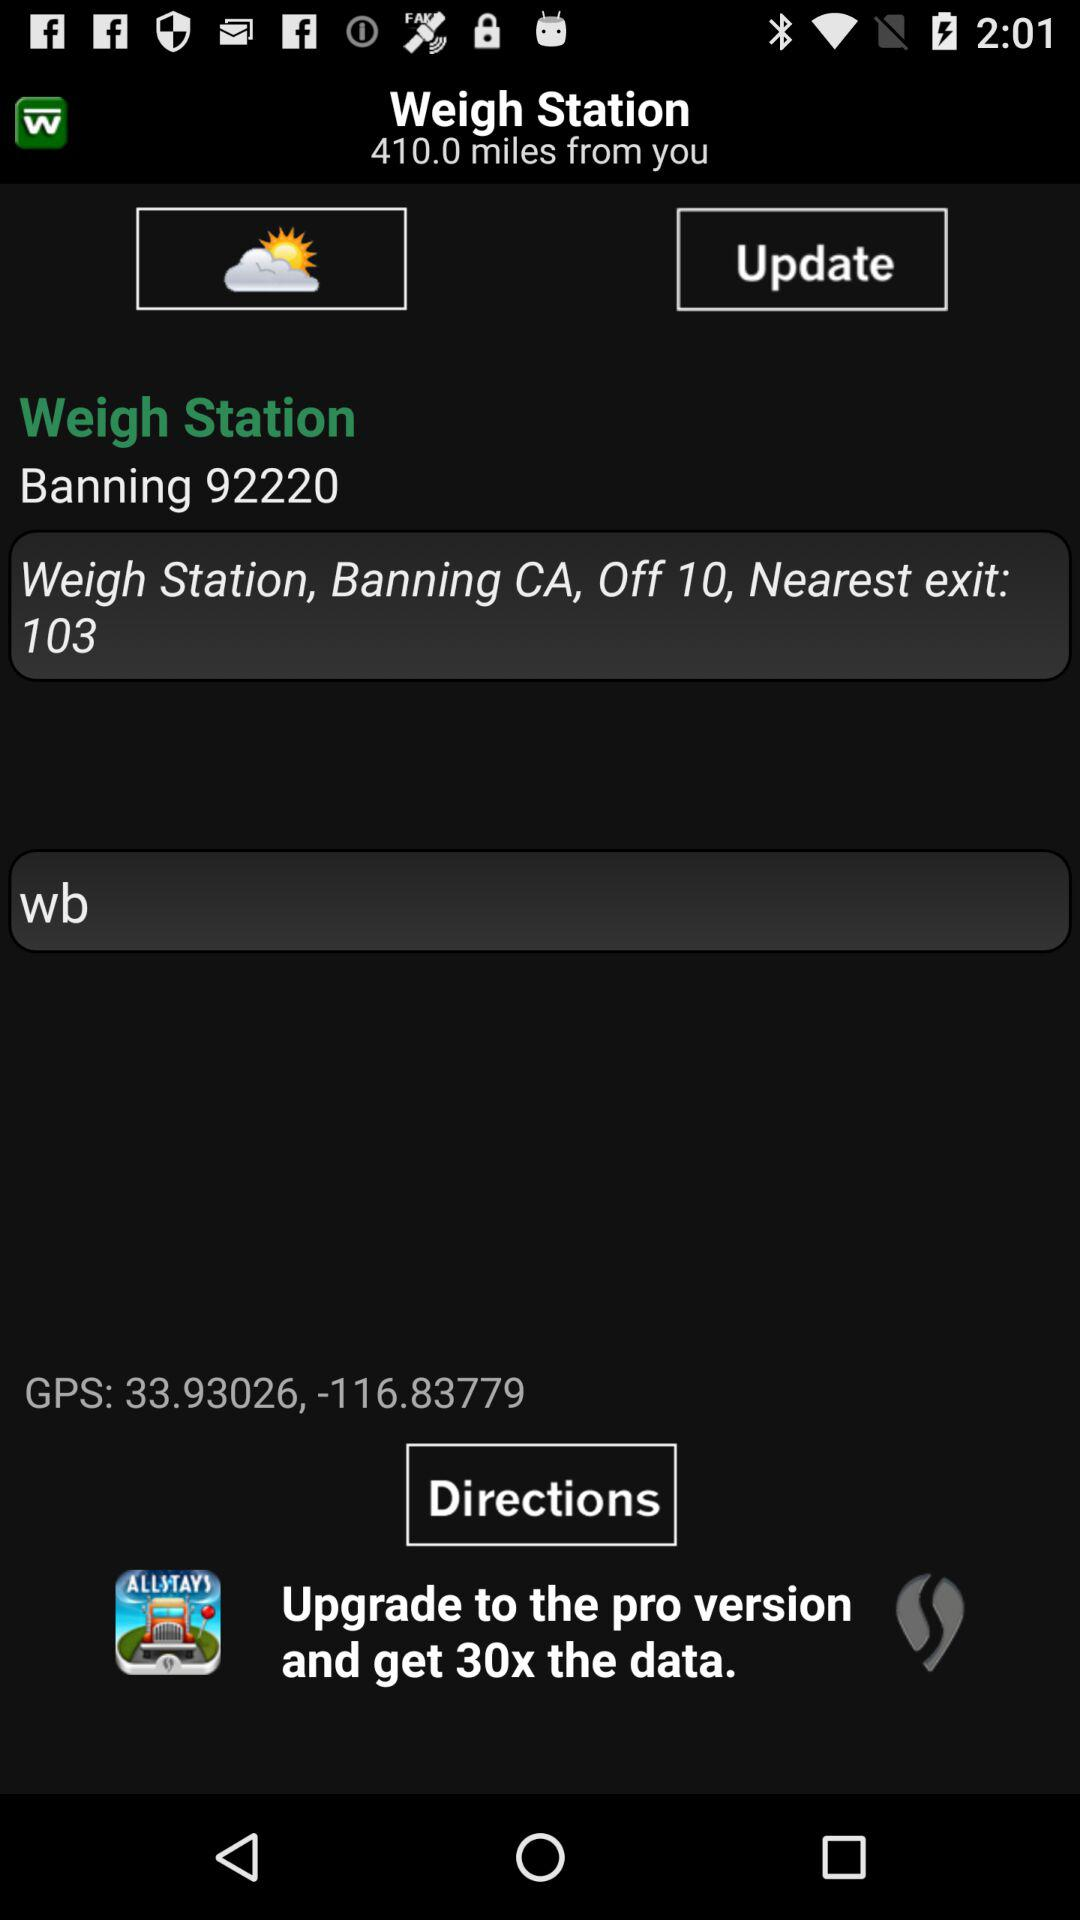What is the location of the weigh station? The location is Banning CA, Off 10. 